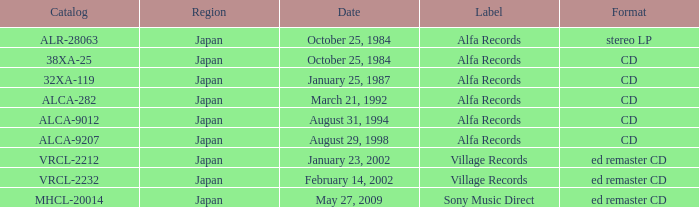What is the catalog of the release from January 23, 2002? VRCL-2212. 